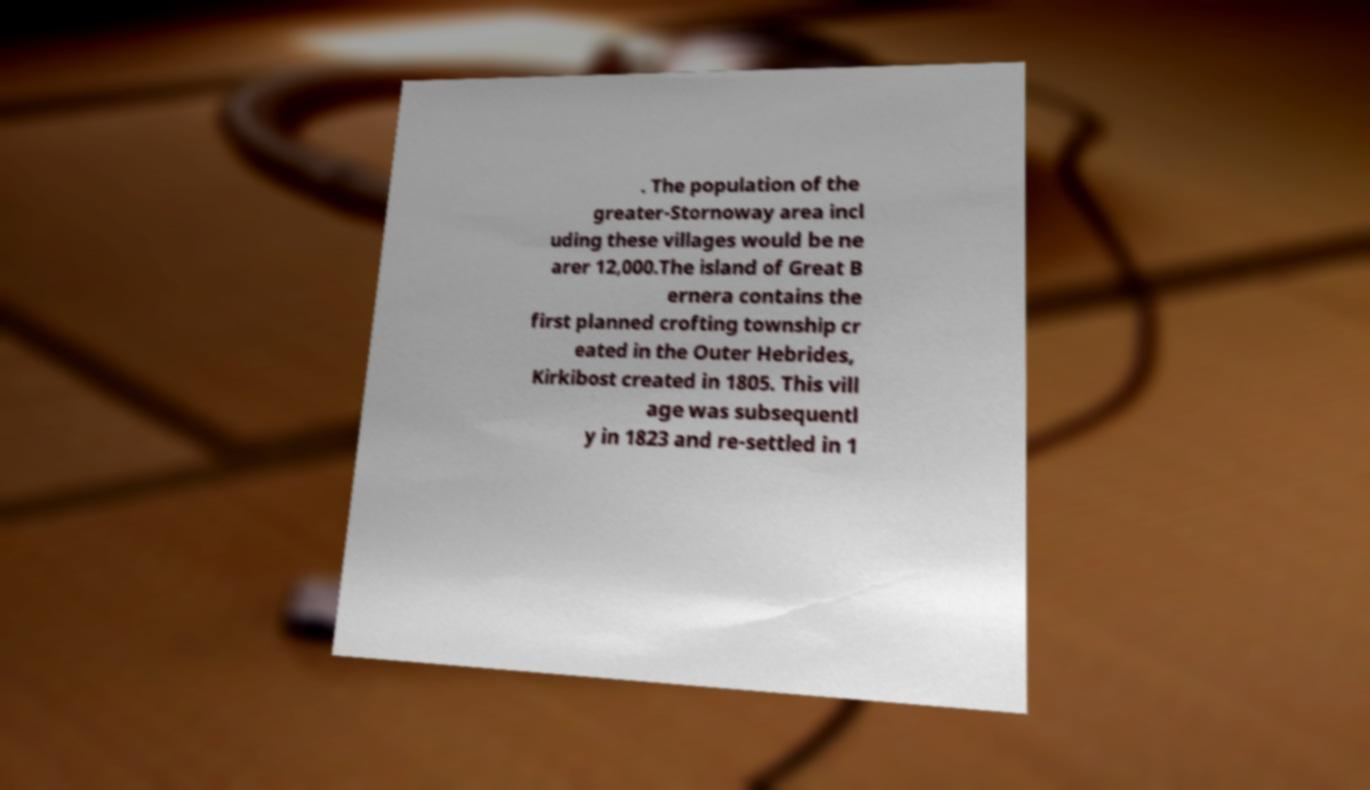Please identify and transcribe the text found in this image. . The population of the greater-Stornoway area incl uding these villages would be ne arer 12,000.The island of Great B ernera contains the first planned crofting township cr eated in the Outer Hebrides, Kirkibost created in 1805. This vill age was subsequentl y in 1823 and re-settled in 1 